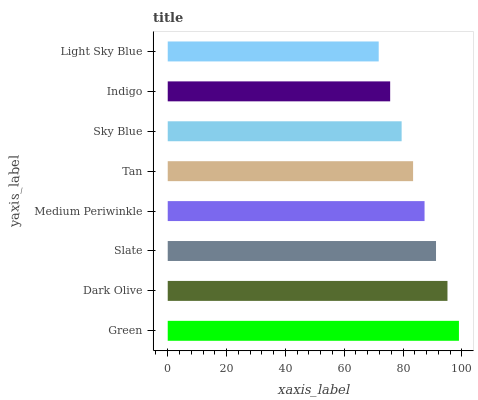Is Light Sky Blue the minimum?
Answer yes or no. Yes. Is Green the maximum?
Answer yes or no. Yes. Is Dark Olive the minimum?
Answer yes or no. No. Is Dark Olive the maximum?
Answer yes or no. No. Is Green greater than Dark Olive?
Answer yes or no. Yes. Is Dark Olive less than Green?
Answer yes or no. Yes. Is Dark Olive greater than Green?
Answer yes or no. No. Is Green less than Dark Olive?
Answer yes or no. No. Is Medium Periwinkle the high median?
Answer yes or no. Yes. Is Tan the low median?
Answer yes or no. Yes. Is Sky Blue the high median?
Answer yes or no. No. Is Medium Periwinkle the low median?
Answer yes or no. No. 